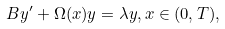<formula> <loc_0><loc_0><loc_500><loc_500>B y ^ { \prime } + \Omega ( x ) y = \lambda y , x \in ( 0 , T ) ,</formula> 